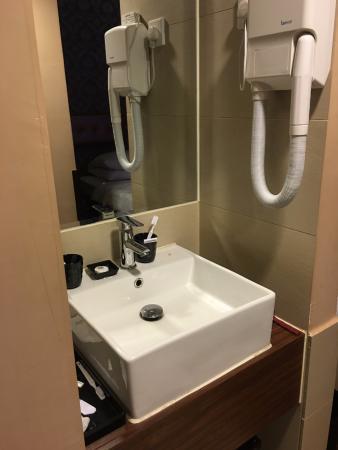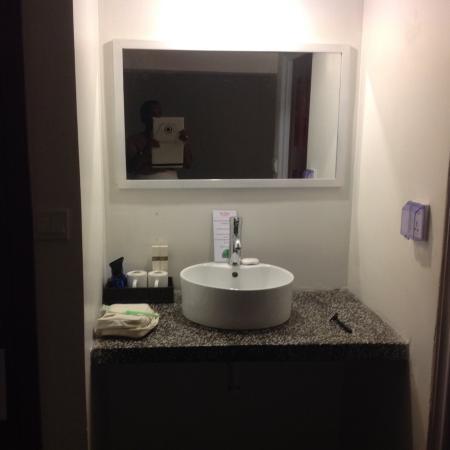The first image is the image on the left, the second image is the image on the right. Analyze the images presented: Is the assertion "In at least one image there is a raised circle basin sink with a mirror behind it." valid? Answer yes or no. Yes. The first image is the image on the left, the second image is the image on the right. Evaluate the accuracy of this statement regarding the images: "One image features a square white sink under a mirror with a counter that spans its tight stall space and does not have a counter beneath it.". Is it true? Answer yes or no. Yes. 